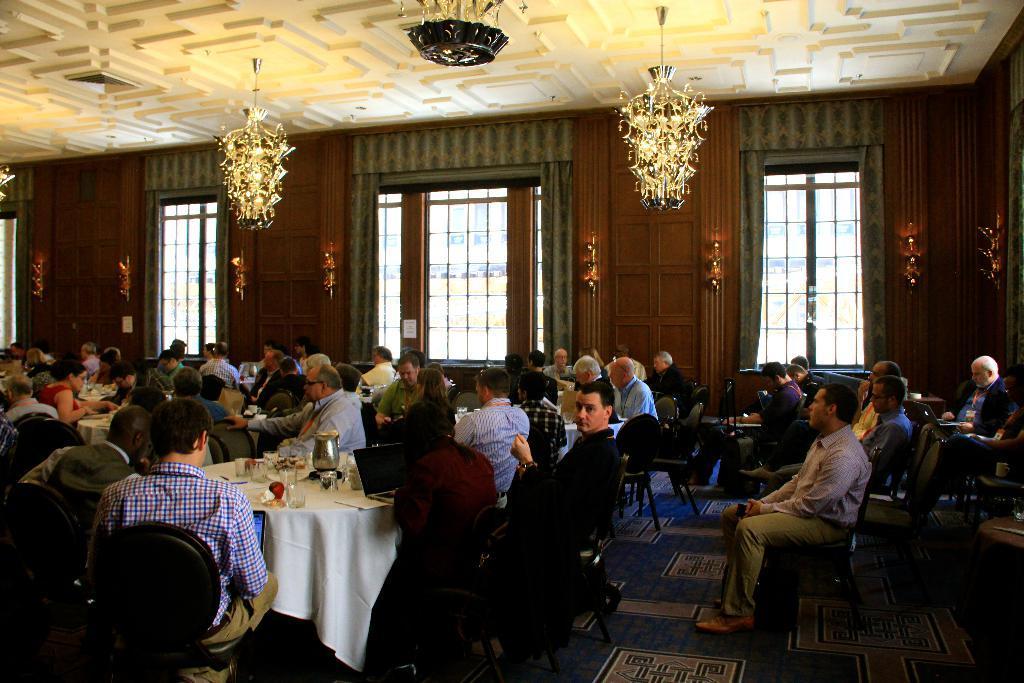Can you describe this image briefly? In this image there are many people sitting in the chairs around the table. There are many things on the table like laptop, jar, water glass, flower vase etc. This is the wall and this is the window glass with curtains. This is the ceiling with chandeliers on the top. 